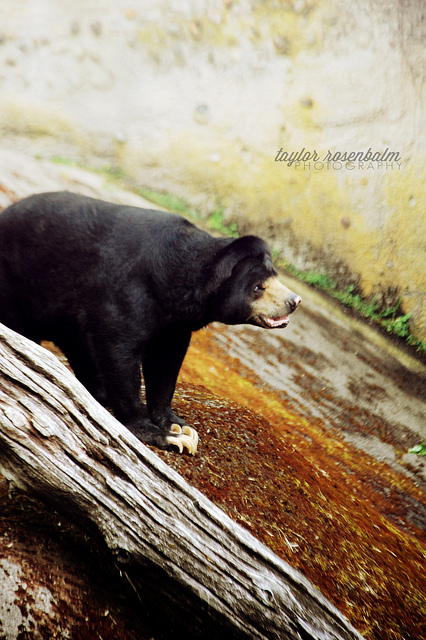Please extract the text content from this image. taylor rosenbalm PHOTOGRAPHY 